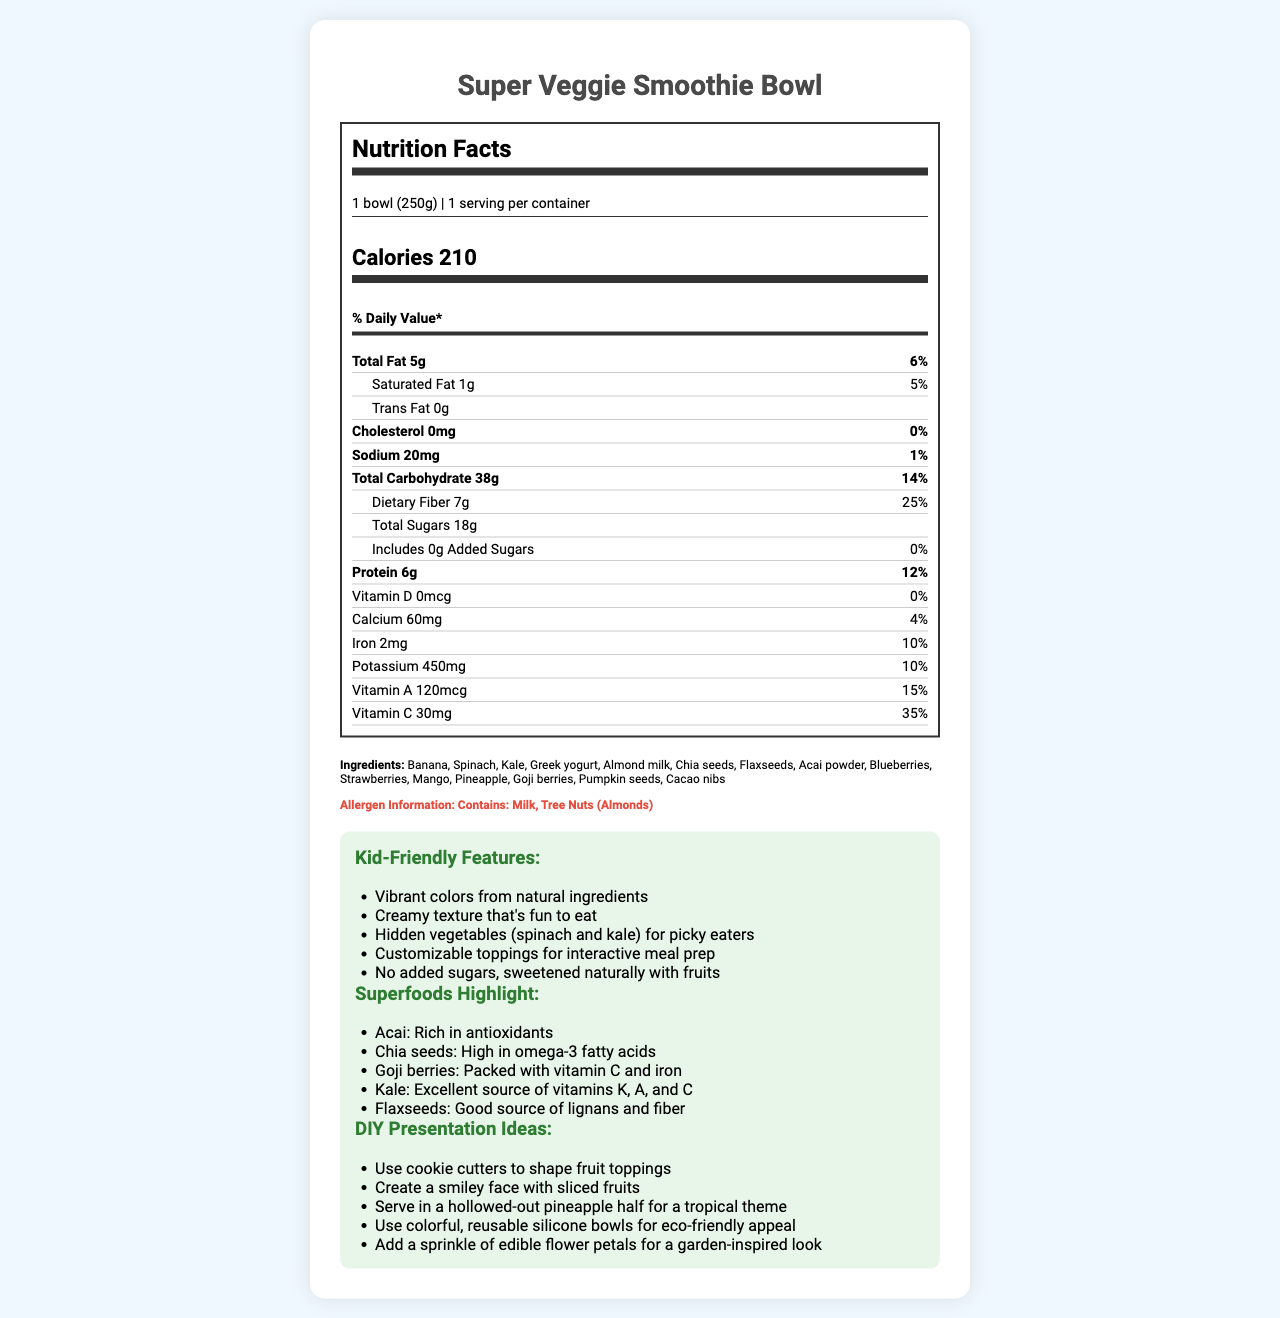what is the serving size for the Super Veggie Smoothie Bowl? The serving size for the Super Veggie Smoothie Bowl is stated as "1 bowl (250g)" in the document.
Answer: 1 bowl (250g) how many calories are in one serving? The nutrition label indicates that one serving contains 210 calories.
Answer: 210 what percentage of the Daily Value does the dietary fiber in the smoothie bowl represent? The document shows that the dietary fiber in the smoothie bowl represents 25% of the Daily Value.
Answer: 25% how much protein does a smoothie bowl contain? The protein content per serving is listed as 6g.
Answer: 6g list three ingredients found in the smoothie bowl. The ingredients listed include Banana, Spinach, and Greek yogurt, among others.
Answer: Banana, Spinach, Greek yogurt which vitamin has the highest percentage of Daily Value? A. Vitamin A B. Vitamin C C. Vitamin D D. Calcium Vitamin C has the highest percentage of Daily Value at 35%, whereas Vitamin A is 15%, Vitamin D is 0%, and Calcium is 4%.
Answer: B. Vitamin C how much potassium is in the smoothie bowl? A. 60mg B. 120mcg C. 450mg D. 30mg The potassium content per serving is 450mg.
Answer: C. 450mg does the smoothie bowl contain any added sugars? The nutrition label indicates that there are 0g of added sugars.
Answer: No is this smoothie bowl free of tree nuts? The allergen information states that the smoothie bowl contains tree nuts (almonds).
Answer: No summarize the main features of the Super Veggie Smoothie Bowl. The document highlights the calorie content, absence of added sugars, significant dietary fiber, and vitamin content of the smoothie bowl. It also focuses on kid-friendly features, superfoods included, and various DIY presentation ideas.
Answer: The Super Veggie Smoothie Bowl is a nutritious option with 210 calories per serving, containing hidden vegetables and superfoods like Acai and Chia seeds. It offers 25% Daily Value of dietary fiber, no added sugars, and is rich in vitamins like Vitamin C. It features dog-friendly textures, vibrant colors, and customizable toppings, making it appealing for kids. what is the preparation tip provided in the document? The preparation tip suggests blending all ingredients except the toppings and then adding desired toppings after pouring into a bowl.
Answer: Blend all ingredients except toppings until smooth. Pour into a bowl and add your favorite toppings like sliced fruits, nuts, or seeds. how much iron does one serving of the smoothie bowl contain? The amount of iron per serving is listed as 2mg.
Answer: 2mg are there any hidden vegetables in the smoothie bowl? The kid-friendly features section mentions hidden vegetables like spinach and kale for picky eaters.
Answer: Yes which superfood mentioned is high in omega-3 fatty acids? According to the superfoods highlight, Chia seeds are high in omega-3 fatty acids.
Answer: Chia seeds what serving container do the DIY presentation ideas suggest for a tropical theme? One of the DIY presentation ideas suggests serving the smoothie bowl in a hollowed-out pineapple half.
Answer: Hollowed-out pineapple half can the exact vitamin content for Vitamin K be determined from the document? The document does not provide any information about the Vitamin K content.
Answer: Not enough information 